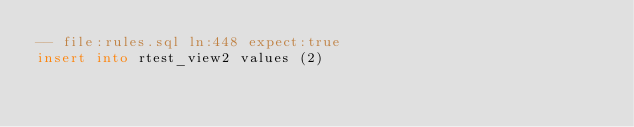Convert code to text. <code><loc_0><loc_0><loc_500><loc_500><_SQL_>-- file:rules.sql ln:448 expect:true
insert into rtest_view2 values (2)
</code> 